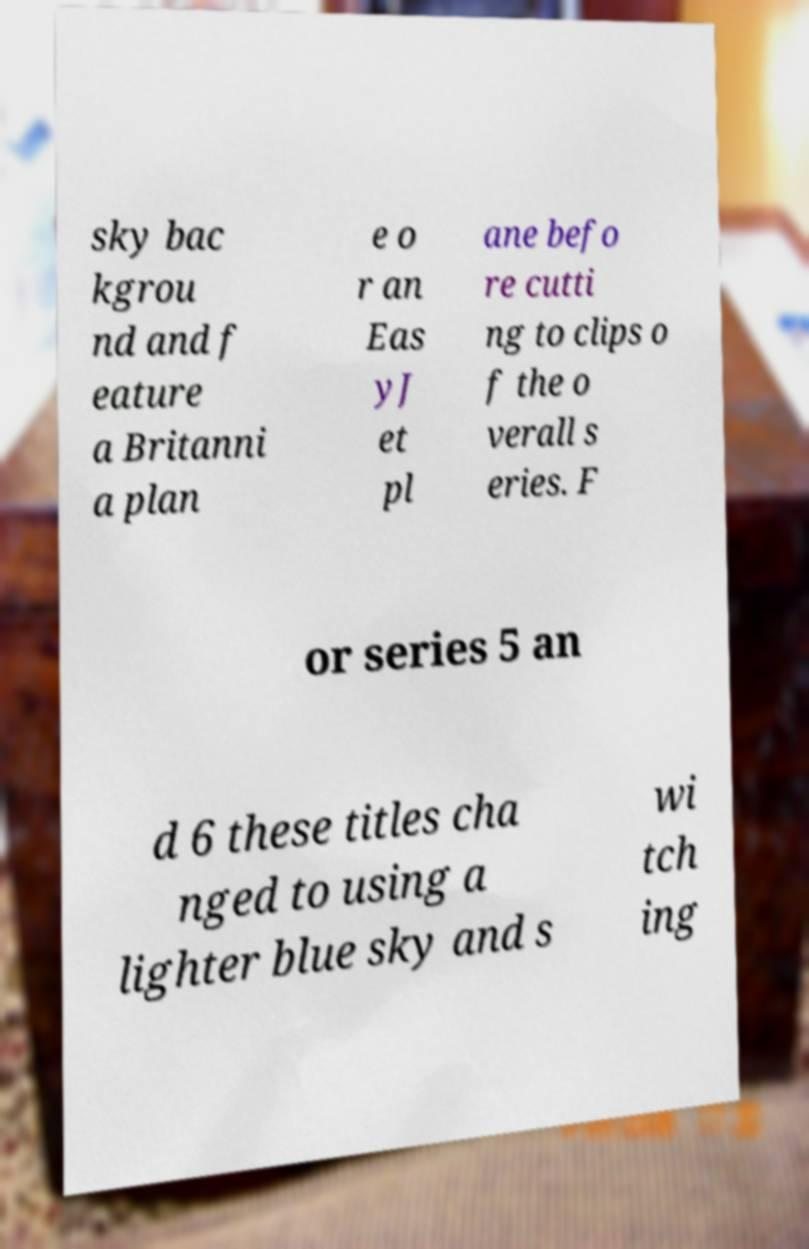Please identify and transcribe the text found in this image. sky bac kgrou nd and f eature a Britanni a plan e o r an Eas yJ et pl ane befo re cutti ng to clips o f the o verall s eries. F or series 5 an d 6 these titles cha nged to using a lighter blue sky and s wi tch ing 